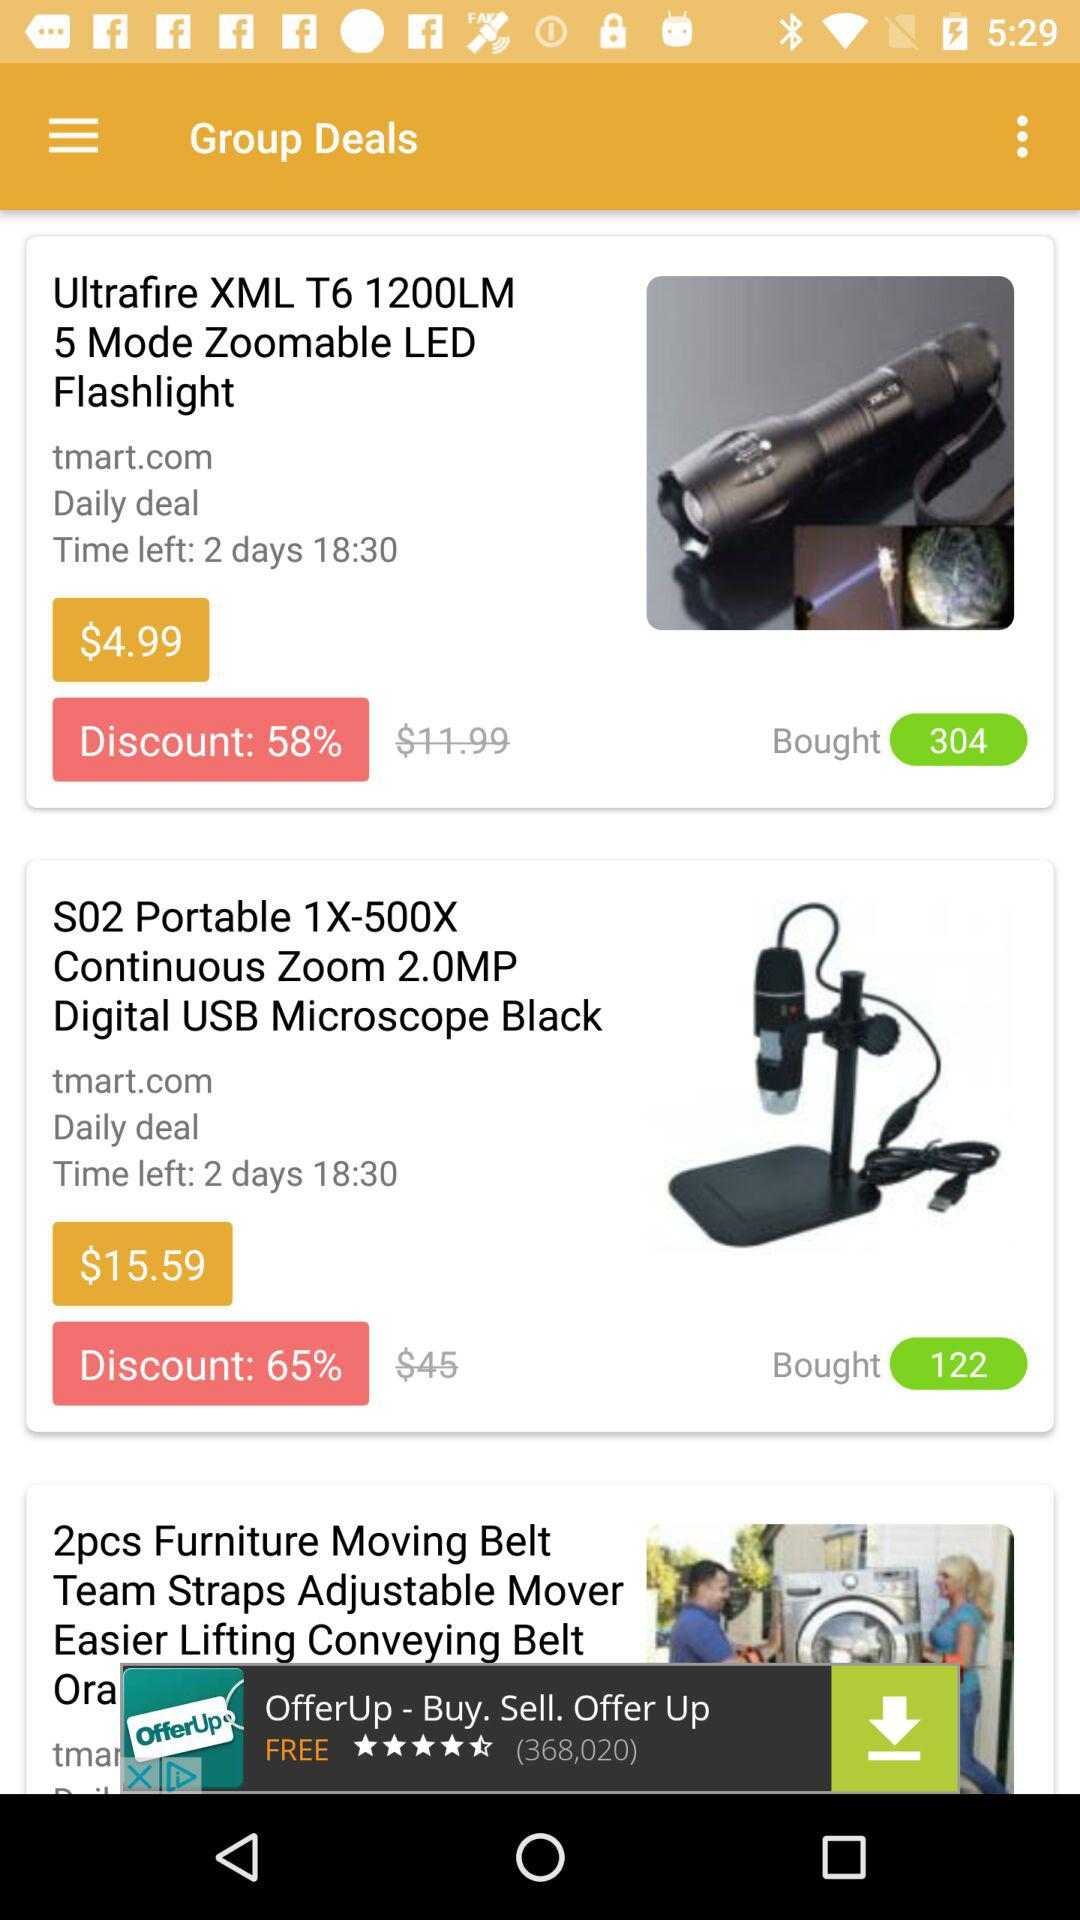How much time is left for the daily deal? The time left for the daily deal is 2 days 18 hours 30 minutes. 